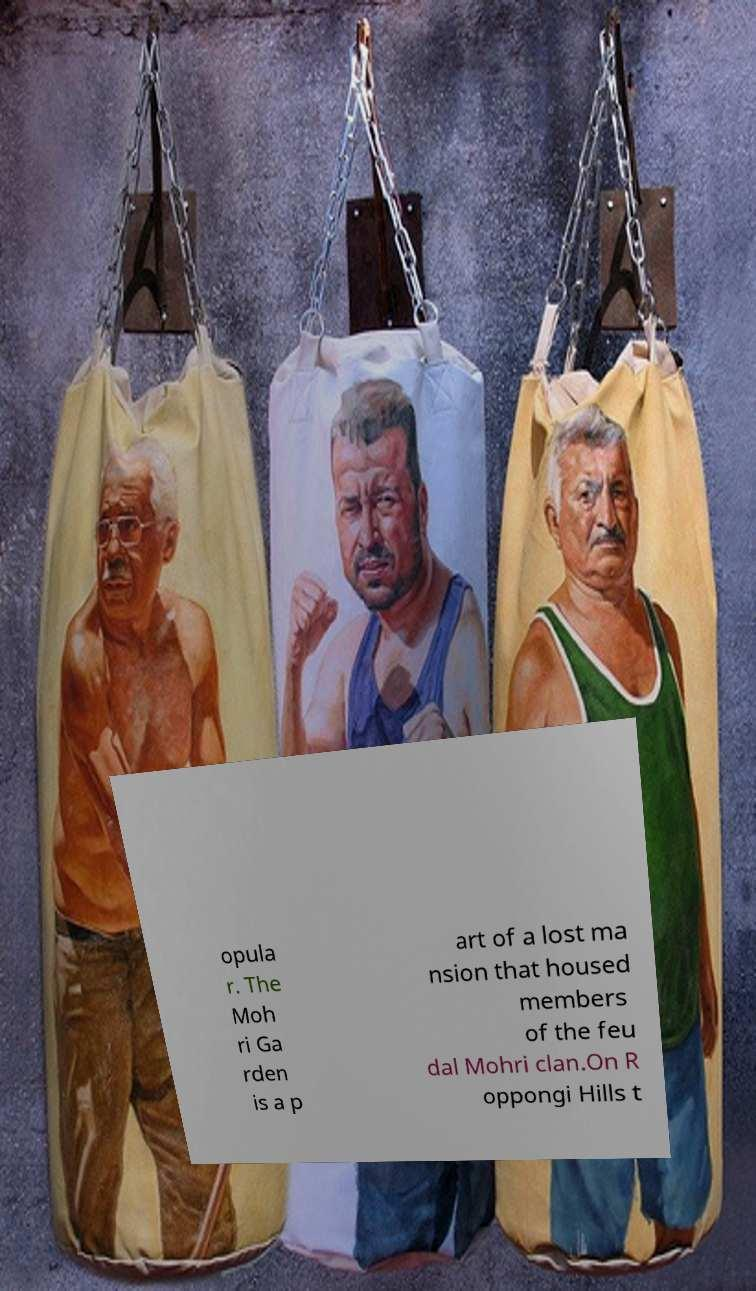What messages or text are displayed in this image? I need them in a readable, typed format. opula r. The Moh ri Ga rden is a p art of a lost ma nsion that housed members of the feu dal Mohri clan.On R oppongi Hills t 